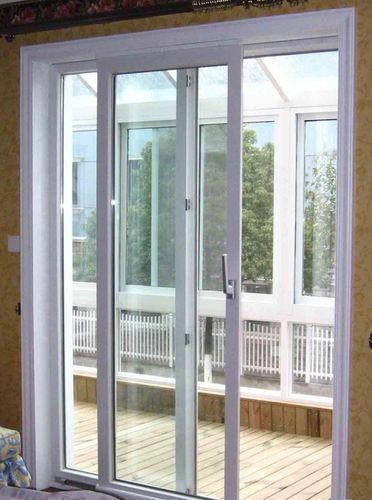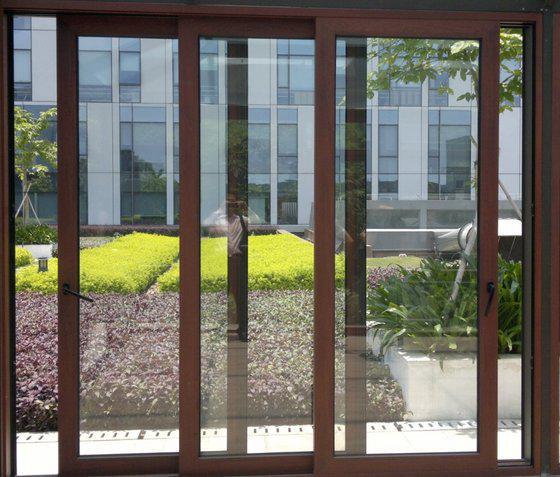The first image is the image on the left, the second image is the image on the right. Assess this claim about the two images: "There is a table and chairs outside the door in the image on the left.". Correct or not? Answer yes or no. No. The first image is the image on the left, the second image is the image on the right. Analyze the images presented: Is the assertion "A sliding glass door unit has three door-shaped sections and no door is open." valid? Answer yes or no. No. 